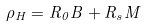<formula> <loc_0><loc_0><loc_500><loc_500>\rho _ { H } = R _ { 0 } B + R _ { s } M</formula> 